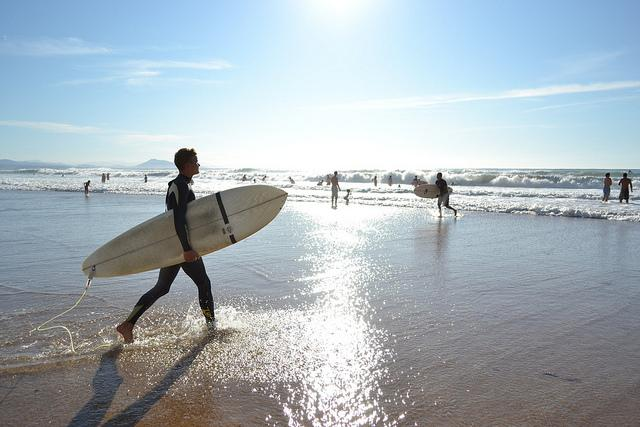What is the man walking to? Please explain your reasoning. ocean. The man is going to the ocean. 